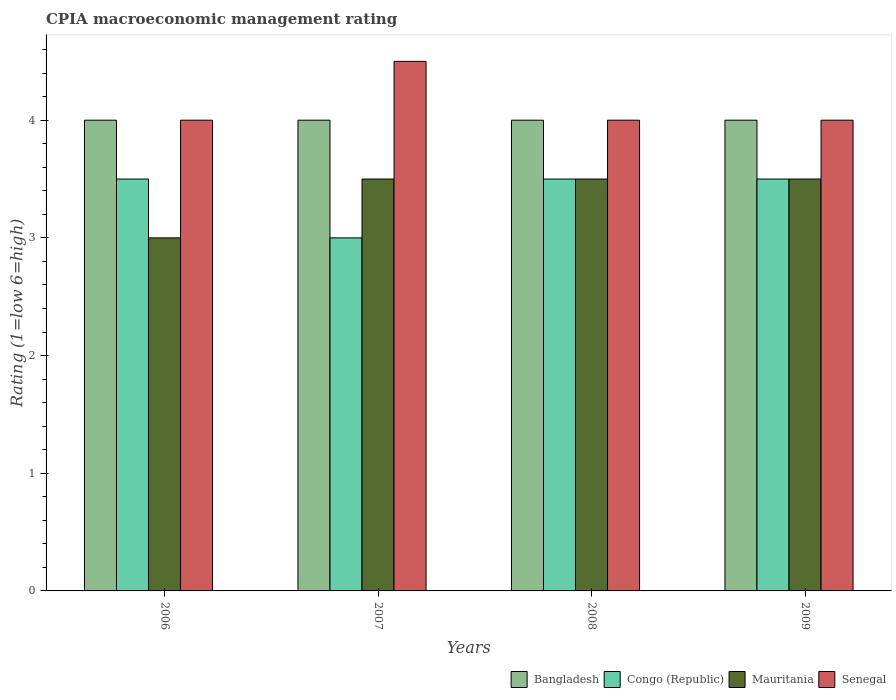How many groups of bars are there?
Your answer should be compact. 4. In how many cases, is the number of bars for a given year not equal to the number of legend labels?
Keep it short and to the point. 0. What is the CPIA rating in Mauritania in 2009?
Offer a terse response. 3.5. In which year was the CPIA rating in Congo (Republic) minimum?
Provide a succinct answer. 2007. What is the average CPIA rating in Bangladesh per year?
Give a very brief answer. 4. In how many years, is the CPIA rating in Senegal greater than 0.6000000000000001?
Provide a succinct answer. 4. Is the CPIA rating in Mauritania in 2008 less than that in 2009?
Give a very brief answer. No. Is the difference between the CPIA rating in Congo (Republic) in 2008 and 2009 greater than the difference between the CPIA rating in Mauritania in 2008 and 2009?
Give a very brief answer. No. What is the difference between the highest and the lowest CPIA rating in Bangladesh?
Provide a succinct answer. 0. In how many years, is the CPIA rating in Mauritania greater than the average CPIA rating in Mauritania taken over all years?
Keep it short and to the point. 3. What does the 3rd bar from the left in 2008 represents?
Provide a short and direct response. Mauritania. How many bars are there?
Your answer should be compact. 16. What is the difference between two consecutive major ticks on the Y-axis?
Provide a short and direct response. 1. Does the graph contain grids?
Keep it short and to the point. No. How are the legend labels stacked?
Make the answer very short. Horizontal. What is the title of the graph?
Your response must be concise. CPIA macroeconomic management rating. What is the label or title of the X-axis?
Provide a succinct answer. Years. What is the label or title of the Y-axis?
Ensure brevity in your answer.  Rating (1=low 6=high). What is the Rating (1=low 6=high) in Senegal in 2006?
Keep it short and to the point. 4. What is the Rating (1=low 6=high) of Congo (Republic) in 2007?
Make the answer very short. 3. What is the Rating (1=low 6=high) in Mauritania in 2007?
Make the answer very short. 3.5. What is the Rating (1=low 6=high) in Congo (Republic) in 2008?
Make the answer very short. 3.5. What is the Rating (1=low 6=high) of Mauritania in 2008?
Your response must be concise. 3.5. What is the Rating (1=low 6=high) of Bangladesh in 2009?
Provide a short and direct response. 4. Across all years, what is the maximum Rating (1=low 6=high) in Congo (Republic)?
Give a very brief answer. 3.5. Across all years, what is the minimum Rating (1=low 6=high) of Congo (Republic)?
Give a very brief answer. 3. Across all years, what is the minimum Rating (1=low 6=high) of Mauritania?
Give a very brief answer. 3. What is the total Rating (1=low 6=high) in Bangladesh in the graph?
Provide a succinct answer. 16. What is the difference between the Rating (1=low 6=high) in Bangladesh in 2006 and that in 2007?
Provide a succinct answer. 0. What is the difference between the Rating (1=low 6=high) of Senegal in 2006 and that in 2007?
Give a very brief answer. -0.5. What is the difference between the Rating (1=low 6=high) of Bangladesh in 2006 and that in 2008?
Your response must be concise. 0. What is the difference between the Rating (1=low 6=high) in Congo (Republic) in 2006 and that in 2008?
Provide a short and direct response. 0. What is the difference between the Rating (1=low 6=high) in Mauritania in 2006 and that in 2008?
Give a very brief answer. -0.5. What is the difference between the Rating (1=low 6=high) of Senegal in 2006 and that in 2008?
Your response must be concise. 0. What is the difference between the Rating (1=low 6=high) in Bangladesh in 2006 and that in 2009?
Provide a short and direct response. 0. What is the difference between the Rating (1=low 6=high) of Mauritania in 2006 and that in 2009?
Offer a terse response. -0.5. What is the difference between the Rating (1=low 6=high) of Congo (Republic) in 2007 and that in 2008?
Make the answer very short. -0.5. What is the difference between the Rating (1=low 6=high) in Bangladesh in 2007 and that in 2009?
Offer a terse response. 0. What is the difference between the Rating (1=low 6=high) of Mauritania in 2008 and that in 2009?
Keep it short and to the point. 0. What is the difference between the Rating (1=low 6=high) of Bangladesh in 2006 and the Rating (1=low 6=high) of Senegal in 2007?
Make the answer very short. -0.5. What is the difference between the Rating (1=low 6=high) in Congo (Republic) in 2006 and the Rating (1=low 6=high) in Senegal in 2007?
Provide a succinct answer. -1. What is the difference between the Rating (1=low 6=high) in Mauritania in 2006 and the Rating (1=low 6=high) in Senegal in 2007?
Offer a very short reply. -1.5. What is the difference between the Rating (1=low 6=high) of Congo (Republic) in 2006 and the Rating (1=low 6=high) of Senegal in 2008?
Provide a short and direct response. -0.5. What is the difference between the Rating (1=low 6=high) of Mauritania in 2006 and the Rating (1=low 6=high) of Senegal in 2008?
Keep it short and to the point. -1. What is the difference between the Rating (1=low 6=high) of Bangladesh in 2006 and the Rating (1=low 6=high) of Congo (Republic) in 2009?
Provide a succinct answer. 0.5. What is the difference between the Rating (1=low 6=high) of Bangladesh in 2007 and the Rating (1=low 6=high) of Mauritania in 2008?
Make the answer very short. 0.5. What is the difference between the Rating (1=low 6=high) in Bangladesh in 2007 and the Rating (1=low 6=high) in Senegal in 2008?
Offer a very short reply. 0. What is the difference between the Rating (1=low 6=high) of Congo (Republic) in 2007 and the Rating (1=low 6=high) of Mauritania in 2008?
Your response must be concise. -0.5. What is the difference between the Rating (1=low 6=high) in Congo (Republic) in 2007 and the Rating (1=low 6=high) in Senegal in 2008?
Provide a succinct answer. -1. What is the difference between the Rating (1=low 6=high) of Mauritania in 2007 and the Rating (1=low 6=high) of Senegal in 2008?
Ensure brevity in your answer.  -0.5. What is the difference between the Rating (1=low 6=high) of Bangladesh in 2007 and the Rating (1=low 6=high) of Congo (Republic) in 2009?
Provide a short and direct response. 0.5. What is the difference between the Rating (1=low 6=high) of Bangladesh in 2007 and the Rating (1=low 6=high) of Senegal in 2009?
Your answer should be very brief. 0. What is the difference between the Rating (1=low 6=high) in Mauritania in 2007 and the Rating (1=low 6=high) in Senegal in 2009?
Provide a succinct answer. -0.5. What is the difference between the Rating (1=low 6=high) of Bangladesh in 2008 and the Rating (1=low 6=high) of Congo (Republic) in 2009?
Give a very brief answer. 0.5. What is the difference between the Rating (1=low 6=high) of Bangladesh in 2008 and the Rating (1=low 6=high) of Senegal in 2009?
Provide a succinct answer. 0. What is the difference between the Rating (1=low 6=high) in Congo (Republic) in 2008 and the Rating (1=low 6=high) in Mauritania in 2009?
Ensure brevity in your answer.  0. What is the difference between the Rating (1=low 6=high) of Congo (Republic) in 2008 and the Rating (1=low 6=high) of Senegal in 2009?
Provide a succinct answer. -0.5. What is the difference between the Rating (1=low 6=high) in Mauritania in 2008 and the Rating (1=low 6=high) in Senegal in 2009?
Your response must be concise. -0.5. What is the average Rating (1=low 6=high) of Congo (Republic) per year?
Keep it short and to the point. 3.38. What is the average Rating (1=low 6=high) of Mauritania per year?
Your answer should be very brief. 3.38. What is the average Rating (1=low 6=high) in Senegal per year?
Make the answer very short. 4.12. In the year 2006, what is the difference between the Rating (1=low 6=high) of Bangladesh and Rating (1=low 6=high) of Congo (Republic)?
Your response must be concise. 0.5. In the year 2006, what is the difference between the Rating (1=low 6=high) in Bangladesh and Rating (1=low 6=high) in Senegal?
Your answer should be compact. 0. In the year 2006, what is the difference between the Rating (1=low 6=high) in Congo (Republic) and Rating (1=low 6=high) in Senegal?
Give a very brief answer. -0.5. In the year 2007, what is the difference between the Rating (1=low 6=high) of Bangladesh and Rating (1=low 6=high) of Congo (Republic)?
Your answer should be compact. 1. In the year 2007, what is the difference between the Rating (1=low 6=high) of Bangladesh and Rating (1=low 6=high) of Senegal?
Make the answer very short. -0.5. In the year 2007, what is the difference between the Rating (1=low 6=high) in Congo (Republic) and Rating (1=low 6=high) in Mauritania?
Your answer should be very brief. -0.5. In the year 2007, what is the difference between the Rating (1=low 6=high) of Congo (Republic) and Rating (1=low 6=high) of Senegal?
Keep it short and to the point. -1.5. In the year 2007, what is the difference between the Rating (1=low 6=high) of Mauritania and Rating (1=low 6=high) of Senegal?
Give a very brief answer. -1. In the year 2008, what is the difference between the Rating (1=low 6=high) of Bangladesh and Rating (1=low 6=high) of Congo (Republic)?
Give a very brief answer. 0.5. In the year 2008, what is the difference between the Rating (1=low 6=high) of Bangladesh and Rating (1=low 6=high) of Senegal?
Provide a succinct answer. 0. In the year 2008, what is the difference between the Rating (1=low 6=high) in Congo (Republic) and Rating (1=low 6=high) in Mauritania?
Offer a very short reply. 0. In the year 2008, what is the difference between the Rating (1=low 6=high) in Congo (Republic) and Rating (1=low 6=high) in Senegal?
Ensure brevity in your answer.  -0.5. In the year 2009, what is the difference between the Rating (1=low 6=high) in Bangladesh and Rating (1=low 6=high) in Senegal?
Provide a short and direct response. 0. In the year 2009, what is the difference between the Rating (1=low 6=high) in Congo (Republic) and Rating (1=low 6=high) in Mauritania?
Keep it short and to the point. 0. In the year 2009, what is the difference between the Rating (1=low 6=high) in Congo (Republic) and Rating (1=low 6=high) in Senegal?
Your response must be concise. -0.5. What is the ratio of the Rating (1=low 6=high) of Senegal in 2006 to that in 2007?
Provide a succinct answer. 0.89. What is the ratio of the Rating (1=low 6=high) in Congo (Republic) in 2006 to that in 2008?
Your answer should be very brief. 1. What is the ratio of the Rating (1=low 6=high) of Mauritania in 2006 to that in 2008?
Offer a very short reply. 0.86. What is the ratio of the Rating (1=low 6=high) in Senegal in 2006 to that in 2008?
Offer a very short reply. 1. What is the ratio of the Rating (1=low 6=high) in Mauritania in 2006 to that in 2009?
Offer a very short reply. 0.86. What is the ratio of the Rating (1=low 6=high) of Senegal in 2006 to that in 2009?
Your answer should be compact. 1. What is the ratio of the Rating (1=low 6=high) of Mauritania in 2007 to that in 2008?
Provide a short and direct response. 1. What is the ratio of the Rating (1=low 6=high) in Senegal in 2007 to that in 2008?
Your answer should be very brief. 1.12. What is the ratio of the Rating (1=low 6=high) of Bangladesh in 2008 to that in 2009?
Your answer should be compact. 1. What is the ratio of the Rating (1=low 6=high) in Congo (Republic) in 2008 to that in 2009?
Keep it short and to the point. 1. What is the ratio of the Rating (1=low 6=high) in Mauritania in 2008 to that in 2009?
Keep it short and to the point. 1. What is the difference between the highest and the second highest Rating (1=low 6=high) in Bangladesh?
Your answer should be compact. 0. What is the difference between the highest and the second highest Rating (1=low 6=high) in Mauritania?
Offer a terse response. 0. What is the difference between the highest and the second highest Rating (1=low 6=high) in Senegal?
Provide a short and direct response. 0.5. What is the difference between the highest and the lowest Rating (1=low 6=high) of Bangladesh?
Make the answer very short. 0. What is the difference between the highest and the lowest Rating (1=low 6=high) of Senegal?
Give a very brief answer. 0.5. 